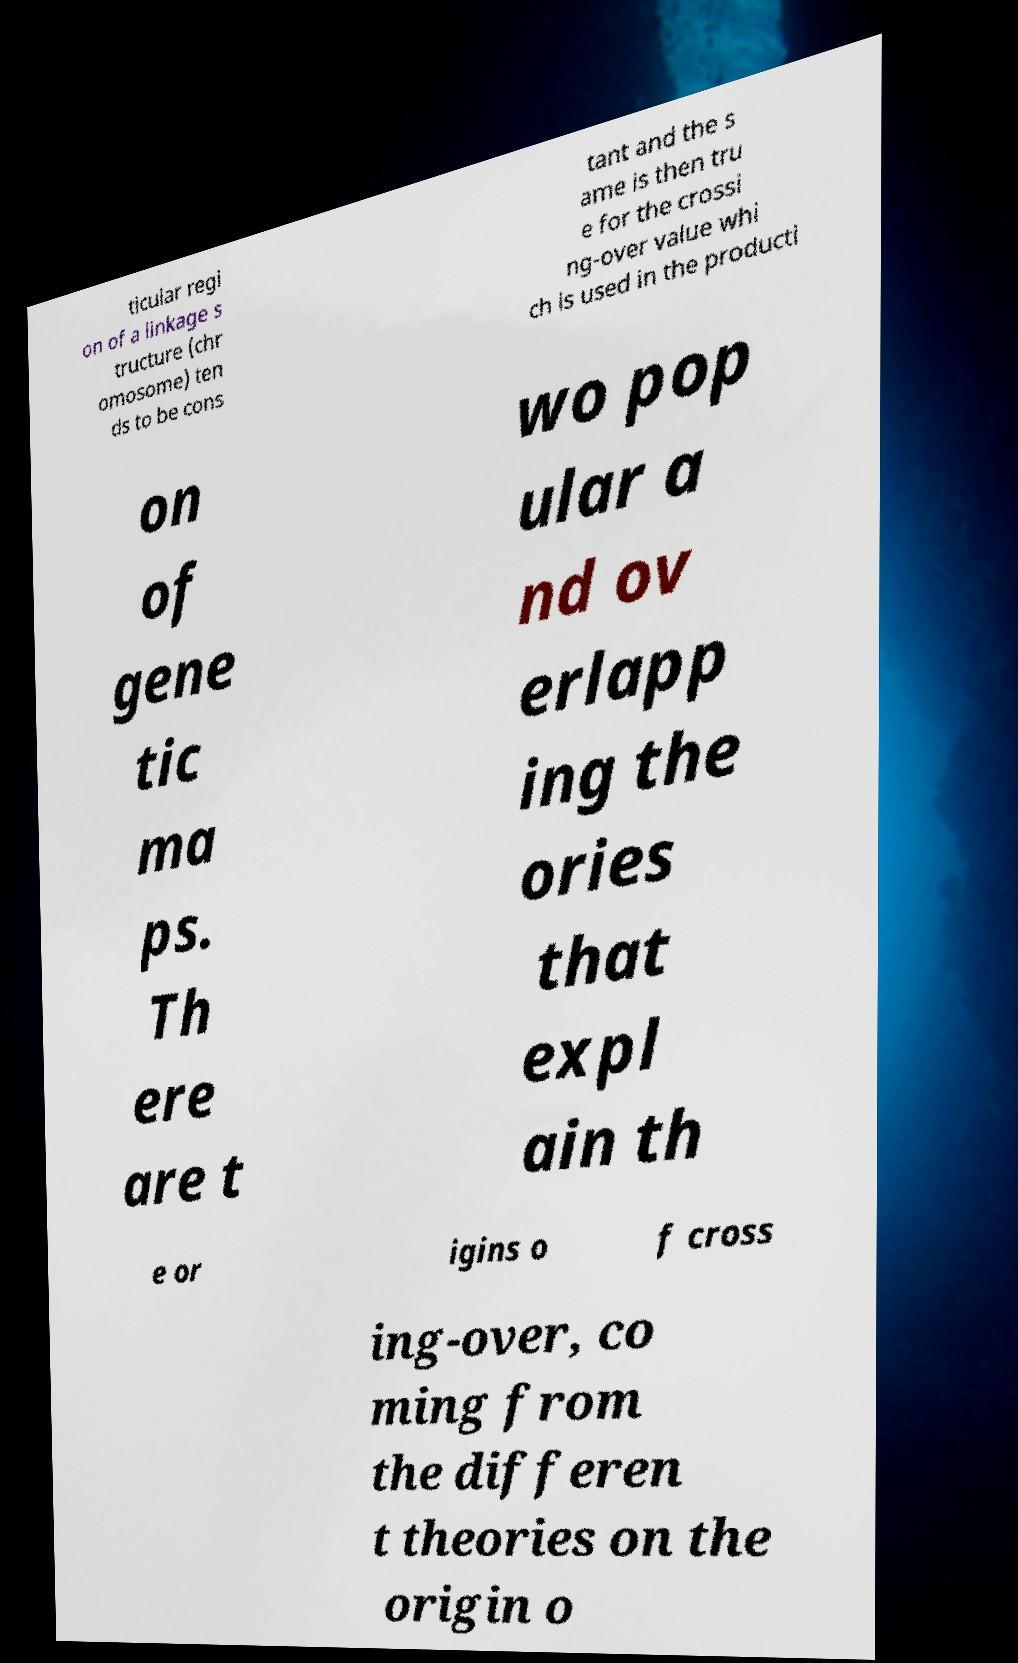Could you assist in decoding the text presented in this image and type it out clearly? ticular regi on of a linkage s tructure (chr omosome) ten ds to be cons tant and the s ame is then tru e for the crossi ng-over value whi ch is used in the producti on of gene tic ma ps. Th ere are t wo pop ular a nd ov erlapp ing the ories that expl ain th e or igins o f cross ing-over, co ming from the differen t theories on the origin o 